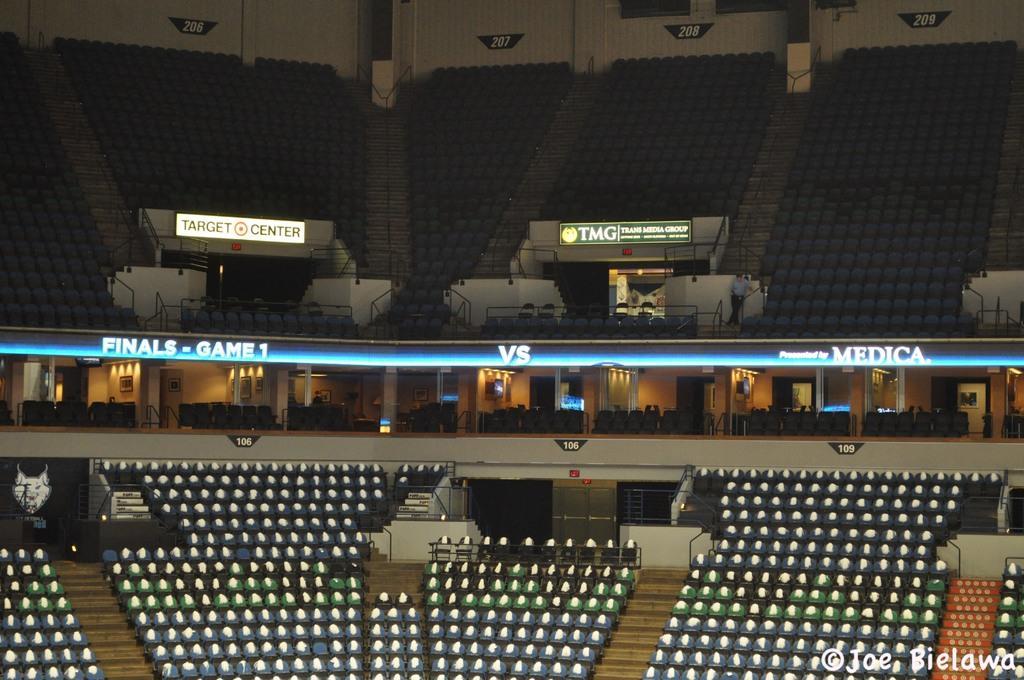How would you summarize this image in a sentence or two? This image is taken in a stadium. In this image there are chairs, railing on the either sides of the stairs, there is a person standing, there are a few lights and a few boards with some text on it. In the background there is a wall. 